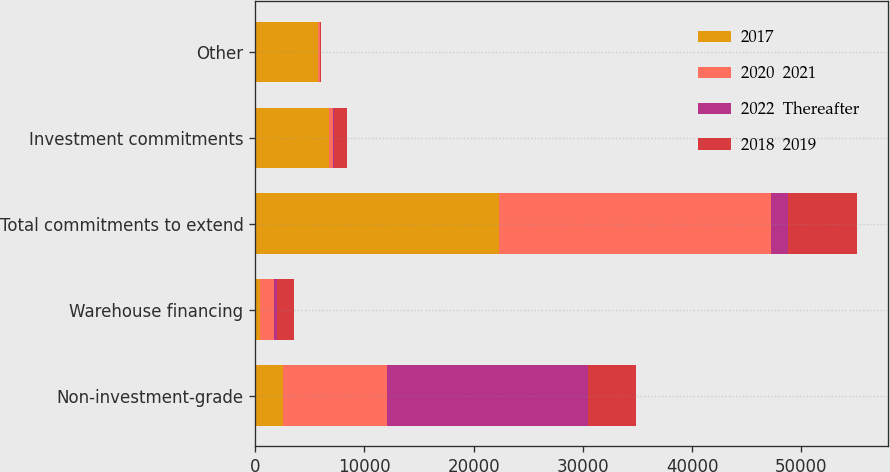Convert chart to OTSL. <chart><loc_0><loc_0><loc_500><loc_500><stacked_bar_chart><ecel><fcel>Non-investment-grade<fcel>Warehouse financing<fcel>Total commitments to extend<fcel>Investment commitments<fcel>Other<nl><fcel>2017<fcel>2562<fcel>388<fcel>22358<fcel>6713<fcel>5756<nl><fcel>2020  2021<fcel>9458<fcel>1356<fcel>24905<fcel>415<fcel>200<nl><fcel>2022  Thereafter<fcel>18484<fcel>263<fcel>1507<fcel>108<fcel>15<nl><fcel>2018  2019<fcel>4374<fcel>1507<fcel>6381<fcel>1208<fcel>43<nl></chart> 